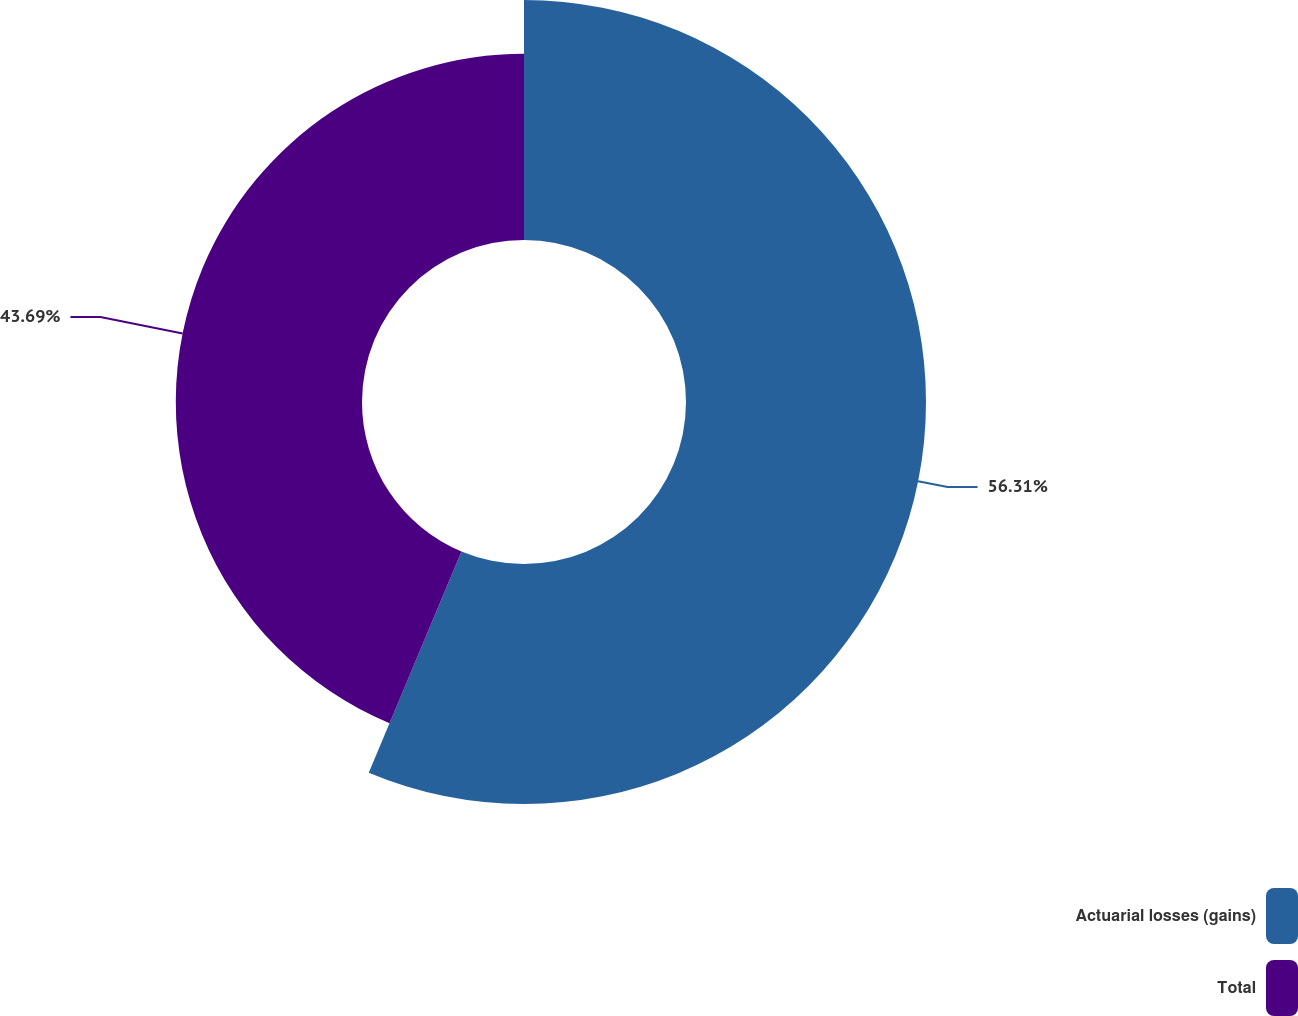Convert chart to OTSL. <chart><loc_0><loc_0><loc_500><loc_500><pie_chart><fcel>Actuarial losses (gains)<fcel>Total<nl><fcel>56.31%<fcel>43.69%<nl></chart> 